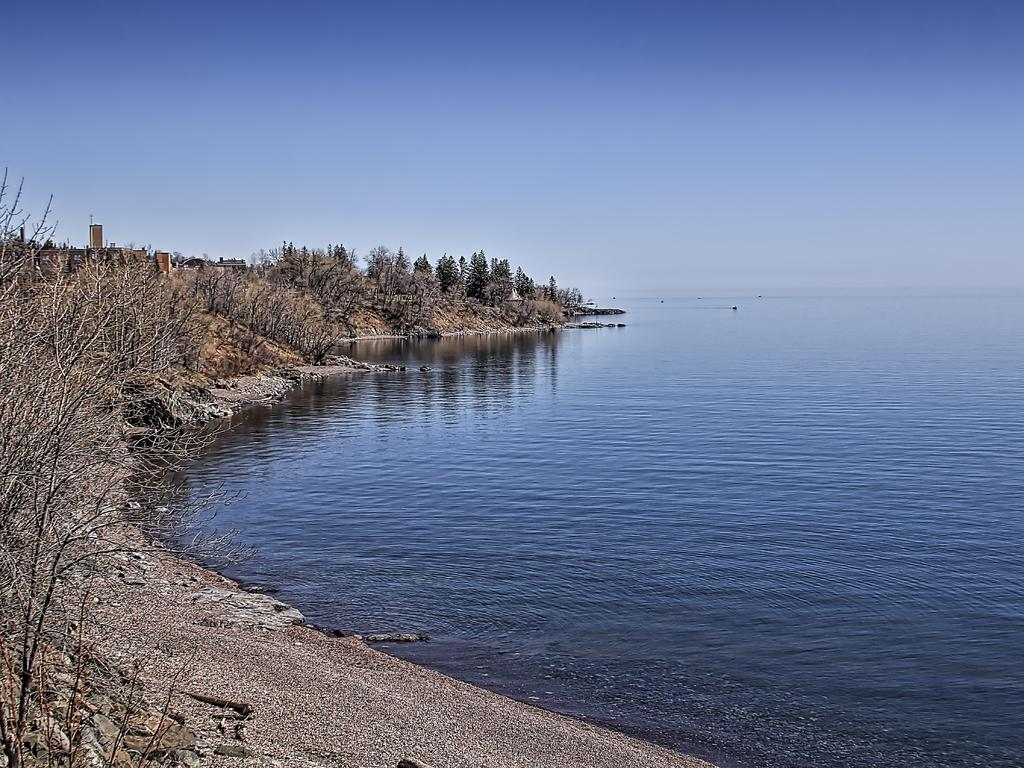What type of vegetation can be seen in the image? There are trees in the image. What natural element is visible in the image besides the trees? There is water visible in the image. What colors are present in the sky in the image? The sky is blue and white in color. What type of pie is being served at the event in the image? There is no event or pie present in the image; it features trees, water, and a blue and white sky. What form does the water take in the image? The water is not depicted in a specific form in the image; it is simply visible as a natural element. 